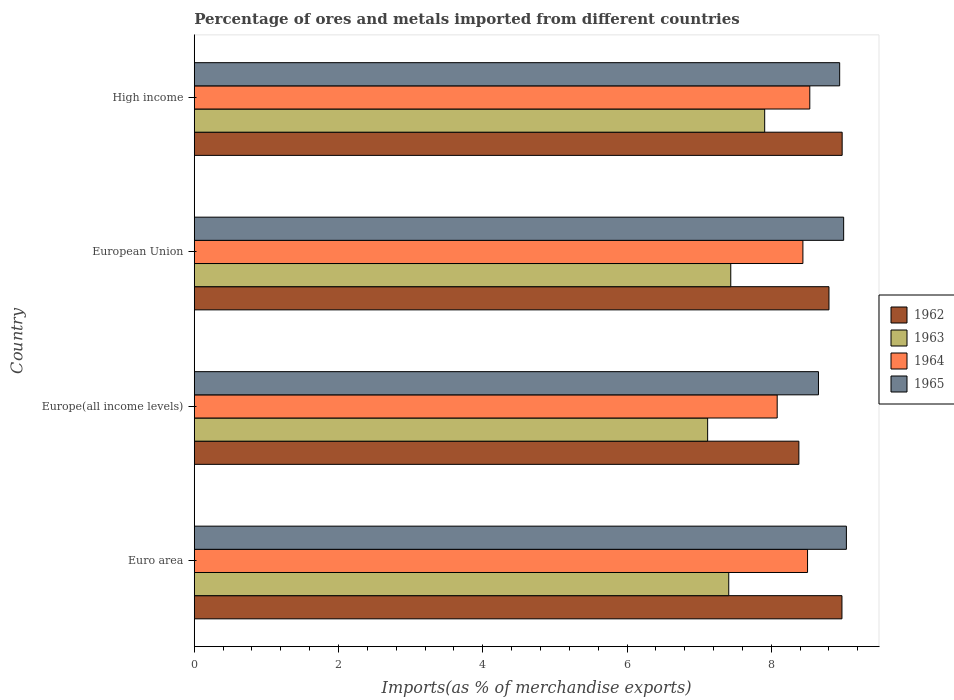How many bars are there on the 1st tick from the top?
Your answer should be very brief. 4. What is the label of the 2nd group of bars from the top?
Ensure brevity in your answer.  European Union. What is the percentage of imports to different countries in 1963 in Euro area?
Offer a very short reply. 7.41. Across all countries, what is the maximum percentage of imports to different countries in 1965?
Offer a very short reply. 9.04. Across all countries, what is the minimum percentage of imports to different countries in 1962?
Provide a succinct answer. 8.38. In which country was the percentage of imports to different countries in 1965 minimum?
Provide a short and direct response. Europe(all income levels). What is the total percentage of imports to different countries in 1963 in the graph?
Offer a very short reply. 29.88. What is the difference between the percentage of imports to different countries in 1964 in Euro area and that in High income?
Ensure brevity in your answer.  -0.03. What is the difference between the percentage of imports to different countries in 1964 in High income and the percentage of imports to different countries in 1965 in Europe(all income levels)?
Offer a very short reply. -0.12. What is the average percentage of imports to different countries in 1963 per country?
Keep it short and to the point. 7.47. What is the difference between the percentage of imports to different countries in 1964 and percentage of imports to different countries in 1965 in European Union?
Keep it short and to the point. -0.56. In how many countries, is the percentage of imports to different countries in 1962 greater than 0.8 %?
Give a very brief answer. 4. What is the ratio of the percentage of imports to different countries in 1963 in Euro area to that in High income?
Offer a terse response. 0.94. Is the percentage of imports to different countries in 1965 in Europe(all income levels) less than that in European Union?
Keep it short and to the point. Yes. Is the difference between the percentage of imports to different countries in 1964 in Euro area and High income greater than the difference between the percentage of imports to different countries in 1965 in Euro area and High income?
Offer a very short reply. No. What is the difference between the highest and the second highest percentage of imports to different countries in 1964?
Give a very brief answer. 0.03. What is the difference between the highest and the lowest percentage of imports to different countries in 1963?
Provide a short and direct response. 0.79. Is the sum of the percentage of imports to different countries in 1965 in Euro area and High income greater than the maximum percentage of imports to different countries in 1964 across all countries?
Provide a succinct answer. Yes. Is it the case that in every country, the sum of the percentage of imports to different countries in 1962 and percentage of imports to different countries in 1965 is greater than the sum of percentage of imports to different countries in 1964 and percentage of imports to different countries in 1963?
Provide a short and direct response. No. What does the 4th bar from the top in European Union represents?
Offer a terse response. 1962. What does the 1st bar from the bottom in Euro area represents?
Provide a succinct answer. 1962. What is the difference between two consecutive major ticks on the X-axis?
Offer a terse response. 2. Are the values on the major ticks of X-axis written in scientific E-notation?
Keep it short and to the point. No. How many legend labels are there?
Keep it short and to the point. 4. What is the title of the graph?
Provide a short and direct response. Percentage of ores and metals imported from different countries. What is the label or title of the X-axis?
Give a very brief answer. Imports(as % of merchandise exports). What is the label or title of the Y-axis?
Your response must be concise. Country. What is the Imports(as % of merchandise exports) in 1962 in Euro area?
Give a very brief answer. 8.98. What is the Imports(as % of merchandise exports) of 1963 in Euro area?
Your response must be concise. 7.41. What is the Imports(as % of merchandise exports) in 1964 in Euro area?
Provide a short and direct response. 8.5. What is the Imports(as % of merchandise exports) in 1965 in Euro area?
Provide a succinct answer. 9.04. What is the Imports(as % of merchandise exports) in 1962 in Europe(all income levels)?
Keep it short and to the point. 8.38. What is the Imports(as % of merchandise exports) in 1963 in Europe(all income levels)?
Your answer should be compact. 7.12. What is the Imports(as % of merchandise exports) of 1964 in Europe(all income levels)?
Give a very brief answer. 8.08. What is the Imports(as % of merchandise exports) of 1965 in Europe(all income levels)?
Your response must be concise. 8.65. What is the Imports(as % of merchandise exports) of 1962 in European Union?
Give a very brief answer. 8.8. What is the Imports(as % of merchandise exports) in 1963 in European Union?
Offer a terse response. 7.44. What is the Imports(as % of merchandise exports) in 1964 in European Union?
Your answer should be very brief. 8.44. What is the Imports(as % of merchandise exports) of 1965 in European Union?
Provide a short and direct response. 9. What is the Imports(as % of merchandise exports) of 1962 in High income?
Provide a succinct answer. 8.98. What is the Imports(as % of merchandise exports) in 1963 in High income?
Give a very brief answer. 7.91. What is the Imports(as % of merchandise exports) in 1964 in High income?
Your answer should be very brief. 8.53. What is the Imports(as % of merchandise exports) in 1965 in High income?
Keep it short and to the point. 8.95. Across all countries, what is the maximum Imports(as % of merchandise exports) in 1962?
Offer a terse response. 8.98. Across all countries, what is the maximum Imports(as % of merchandise exports) of 1963?
Make the answer very short. 7.91. Across all countries, what is the maximum Imports(as % of merchandise exports) of 1964?
Keep it short and to the point. 8.53. Across all countries, what is the maximum Imports(as % of merchandise exports) in 1965?
Keep it short and to the point. 9.04. Across all countries, what is the minimum Imports(as % of merchandise exports) of 1962?
Offer a terse response. 8.38. Across all countries, what is the minimum Imports(as % of merchandise exports) in 1963?
Your response must be concise. 7.12. Across all countries, what is the minimum Imports(as % of merchandise exports) in 1964?
Give a very brief answer. 8.08. Across all countries, what is the minimum Imports(as % of merchandise exports) of 1965?
Ensure brevity in your answer.  8.65. What is the total Imports(as % of merchandise exports) of 1962 in the graph?
Offer a very short reply. 35.15. What is the total Imports(as % of merchandise exports) of 1963 in the graph?
Your answer should be very brief. 29.88. What is the total Imports(as % of merchandise exports) in 1964 in the graph?
Make the answer very short. 33.56. What is the total Imports(as % of merchandise exports) in 1965 in the graph?
Provide a short and direct response. 35.65. What is the difference between the Imports(as % of merchandise exports) in 1962 in Euro area and that in Europe(all income levels)?
Keep it short and to the point. 0.6. What is the difference between the Imports(as % of merchandise exports) of 1963 in Euro area and that in Europe(all income levels)?
Offer a terse response. 0.29. What is the difference between the Imports(as % of merchandise exports) of 1964 in Euro area and that in Europe(all income levels)?
Provide a succinct answer. 0.42. What is the difference between the Imports(as % of merchandise exports) of 1965 in Euro area and that in Europe(all income levels)?
Your answer should be compact. 0.39. What is the difference between the Imports(as % of merchandise exports) in 1962 in Euro area and that in European Union?
Ensure brevity in your answer.  0.18. What is the difference between the Imports(as % of merchandise exports) in 1963 in Euro area and that in European Union?
Your answer should be very brief. -0.03. What is the difference between the Imports(as % of merchandise exports) of 1964 in Euro area and that in European Union?
Your answer should be very brief. 0.06. What is the difference between the Imports(as % of merchandise exports) in 1965 in Euro area and that in European Union?
Provide a short and direct response. 0.04. What is the difference between the Imports(as % of merchandise exports) of 1962 in Euro area and that in High income?
Offer a terse response. -0. What is the difference between the Imports(as % of merchandise exports) of 1963 in Euro area and that in High income?
Your answer should be very brief. -0.5. What is the difference between the Imports(as % of merchandise exports) of 1964 in Euro area and that in High income?
Provide a succinct answer. -0.03. What is the difference between the Imports(as % of merchandise exports) of 1965 in Euro area and that in High income?
Keep it short and to the point. 0.09. What is the difference between the Imports(as % of merchandise exports) in 1962 in Europe(all income levels) and that in European Union?
Offer a very short reply. -0.42. What is the difference between the Imports(as % of merchandise exports) in 1963 in Europe(all income levels) and that in European Union?
Your answer should be very brief. -0.32. What is the difference between the Imports(as % of merchandise exports) of 1964 in Europe(all income levels) and that in European Union?
Give a very brief answer. -0.36. What is the difference between the Imports(as % of merchandise exports) in 1965 in Europe(all income levels) and that in European Union?
Your answer should be compact. -0.35. What is the difference between the Imports(as % of merchandise exports) in 1962 in Europe(all income levels) and that in High income?
Provide a succinct answer. -0.6. What is the difference between the Imports(as % of merchandise exports) in 1963 in Europe(all income levels) and that in High income?
Your response must be concise. -0.79. What is the difference between the Imports(as % of merchandise exports) of 1964 in Europe(all income levels) and that in High income?
Provide a succinct answer. -0.45. What is the difference between the Imports(as % of merchandise exports) in 1965 in Europe(all income levels) and that in High income?
Offer a very short reply. -0.29. What is the difference between the Imports(as % of merchandise exports) of 1962 in European Union and that in High income?
Make the answer very short. -0.18. What is the difference between the Imports(as % of merchandise exports) in 1963 in European Union and that in High income?
Your answer should be very brief. -0.47. What is the difference between the Imports(as % of merchandise exports) in 1964 in European Union and that in High income?
Make the answer very short. -0.1. What is the difference between the Imports(as % of merchandise exports) of 1965 in European Union and that in High income?
Provide a succinct answer. 0.06. What is the difference between the Imports(as % of merchandise exports) of 1962 in Euro area and the Imports(as % of merchandise exports) of 1963 in Europe(all income levels)?
Your answer should be compact. 1.86. What is the difference between the Imports(as % of merchandise exports) in 1962 in Euro area and the Imports(as % of merchandise exports) in 1964 in Europe(all income levels)?
Make the answer very short. 0.9. What is the difference between the Imports(as % of merchandise exports) of 1962 in Euro area and the Imports(as % of merchandise exports) of 1965 in Europe(all income levels)?
Ensure brevity in your answer.  0.33. What is the difference between the Imports(as % of merchandise exports) of 1963 in Euro area and the Imports(as % of merchandise exports) of 1964 in Europe(all income levels)?
Provide a short and direct response. -0.67. What is the difference between the Imports(as % of merchandise exports) of 1963 in Euro area and the Imports(as % of merchandise exports) of 1965 in Europe(all income levels)?
Ensure brevity in your answer.  -1.24. What is the difference between the Imports(as % of merchandise exports) in 1964 in Euro area and the Imports(as % of merchandise exports) in 1965 in Europe(all income levels)?
Provide a succinct answer. -0.15. What is the difference between the Imports(as % of merchandise exports) in 1962 in Euro area and the Imports(as % of merchandise exports) in 1963 in European Union?
Your answer should be very brief. 1.54. What is the difference between the Imports(as % of merchandise exports) of 1962 in Euro area and the Imports(as % of merchandise exports) of 1964 in European Union?
Your answer should be very brief. 0.54. What is the difference between the Imports(as % of merchandise exports) of 1962 in Euro area and the Imports(as % of merchandise exports) of 1965 in European Union?
Keep it short and to the point. -0.02. What is the difference between the Imports(as % of merchandise exports) of 1963 in Euro area and the Imports(as % of merchandise exports) of 1964 in European Union?
Offer a very short reply. -1.03. What is the difference between the Imports(as % of merchandise exports) in 1963 in Euro area and the Imports(as % of merchandise exports) in 1965 in European Union?
Your answer should be very brief. -1.59. What is the difference between the Imports(as % of merchandise exports) in 1964 in Euro area and the Imports(as % of merchandise exports) in 1965 in European Union?
Your response must be concise. -0.5. What is the difference between the Imports(as % of merchandise exports) of 1962 in Euro area and the Imports(as % of merchandise exports) of 1963 in High income?
Ensure brevity in your answer.  1.07. What is the difference between the Imports(as % of merchandise exports) in 1962 in Euro area and the Imports(as % of merchandise exports) in 1964 in High income?
Offer a terse response. 0.45. What is the difference between the Imports(as % of merchandise exports) of 1962 in Euro area and the Imports(as % of merchandise exports) of 1965 in High income?
Give a very brief answer. 0.03. What is the difference between the Imports(as % of merchandise exports) of 1963 in Euro area and the Imports(as % of merchandise exports) of 1964 in High income?
Your answer should be compact. -1.12. What is the difference between the Imports(as % of merchandise exports) of 1963 in Euro area and the Imports(as % of merchandise exports) of 1965 in High income?
Make the answer very short. -1.54. What is the difference between the Imports(as % of merchandise exports) in 1964 in Euro area and the Imports(as % of merchandise exports) in 1965 in High income?
Ensure brevity in your answer.  -0.45. What is the difference between the Imports(as % of merchandise exports) in 1962 in Europe(all income levels) and the Imports(as % of merchandise exports) in 1963 in European Union?
Your answer should be very brief. 0.94. What is the difference between the Imports(as % of merchandise exports) in 1962 in Europe(all income levels) and the Imports(as % of merchandise exports) in 1964 in European Union?
Provide a short and direct response. -0.06. What is the difference between the Imports(as % of merchandise exports) in 1962 in Europe(all income levels) and the Imports(as % of merchandise exports) in 1965 in European Union?
Your answer should be very brief. -0.62. What is the difference between the Imports(as % of merchandise exports) of 1963 in Europe(all income levels) and the Imports(as % of merchandise exports) of 1964 in European Union?
Provide a short and direct response. -1.32. What is the difference between the Imports(as % of merchandise exports) in 1963 in Europe(all income levels) and the Imports(as % of merchandise exports) in 1965 in European Union?
Provide a succinct answer. -1.89. What is the difference between the Imports(as % of merchandise exports) in 1964 in Europe(all income levels) and the Imports(as % of merchandise exports) in 1965 in European Union?
Provide a short and direct response. -0.92. What is the difference between the Imports(as % of merchandise exports) of 1962 in Europe(all income levels) and the Imports(as % of merchandise exports) of 1963 in High income?
Give a very brief answer. 0.47. What is the difference between the Imports(as % of merchandise exports) of 1962 in Europe(all income levels) and the Imports(as % of merchandise exports) of 1964 in High income?
Offer a terse response. -0.15. What is the difference between the Imports(as % of merchandise exports) in 1962 in Europe(all income levels) and the Imports(as % of merchandise exports) in 1965 in High income?
Provide a succinct answer. -0.57. What is the difference between the Imports(as % of merchandise exports) of 1963 in Europe(all income levels) and the Imports(as % of merchandise exports) of 1964 in High income?
Your answer should be very brief. -1.42. What is the difference between the Imports(as % of merchandise exports) of 1963 in Europe(all income levels) and the Imports(as % of merchandise exports) of 1965 in High income?
Offer a very short reply. -1.83. What is the difference between the Imports(as % of merchandise exports) in 1964 in Europe(all income levels) and the Imports(as % of merchandise exports) in 1965 in High income?
Your answer should be very brief. -0.87. What is the difference between the Imports(as % of merchandise exports) in 1962 in European Union and the Imports(as % of merchandise exports) in 1963 in High income?
Offer a terse response. 0.89. What is the difference between the Imports(as % of merchandise exports) in 1962 in European Union and the Imports(as % of merchandise exports) in 1964 in High income?
Keep it short and to the point. 0.27. What is the difference between the Imports(as % of merchandise exports) in 1962 in European Union and the Imports(as % of merchandise exports) in 1965 in High income?
Give a very brief answer. -0.15. What is the difference between the Imports(as % of merchandise exports) in 1963 in European Union and the Imports(as % of merchandise exports) in 1964 in High income?
Keep it short and to the point. -1.1. What is the difference between the Imports(as % of merchandise exports) of 1963 in European Union and the Imports(as % of merchandise exports) of 1965 in High income?
Provide a succinct answer. -1.51. What is the difference between the Imports(as % of merchandise exports) of 1964 in European Union and the Imports(as % of merchandise exports) of 1965 in High income?
Your answer should be very brief. -0.51. What is the average Imports(as % of merchandise exports) of 1962 per country?
Provide a succinct answer. 8.79. What is the average Imports(as % of merchandise exports) in 1963 per country?
Keep it short and to the point. 7.47. What is the average Imports(as % of merchandise exports) in 1964 per country?
Offer a very short reply. 8.39. What is the average Imports(as % of merchandise exports) in 1965 per country?
Make the answer very short. 8.91. What is the difference between the Imports(as % of merchandise exports) of 1962 and Imports(as % of merchandise exports) of 1963 in Euro area?
Your answer should be very brief. 1.57. What is the difference between the Imports(as % of merchandise exports) of 1962 and Imports(as % of merchandise exports) of 1964 in Euro area?
Your response must be concise. 0.48. What is the difference between the Imports(as % of merchandise exports) of 1962 and Imports(as % of merchandise exports) of 1965 in Euro area?
Your response must be concise. -0.06. What is the difference between the Imports(as % of merchandise exports) in 1963 and Imports(as % of merchandise exports) in 1964 in Euro area?
Your answer should be very brief. -1.09. What is the difference between the Imports(as % of merchandise exports) of 1963 and Imports(as % of merchandise exports) of 1965 in Euro area?
Offer a very short reply. -1.63. What is the difference between the Imports(as % of merchandise exports) in 1964 and Imports(as % of merchandise exports) in 1965 in Euro area?
Offer a terse response. -0.54. What is the difference between the Imports(as % of merchandise exports) in 1962 and Imports(as % of merchandise exports) in 1963 in Europe(all income levels)?
Provide a short and direct response. 1.26. What is the difference between the Imports(as % of merchandise exports) in 1962 and Imports(as % of merchandise exports) in 1964 in Europe(all income levels)?
Give a very brief answer. 0.3. What is the difference between the Imports(as % of merchandise exports) in 1962 and Imports(as % of merchandise exports) in 1965 in Europe(all income levels)?
Offer a very short reply. -0.27. What is the difference between the Imports(as % of merchandise exports) of 1963 and Imports(as % of merchandise exports) of 1964 in Europe(all income levels)?
Provide a short and direct response. -0.96. What is the difference between the Imports(as % of merchandise exports) in 1963 and Imports(as % of merchandise exports) in 1965 in Europe(all income levels)?
Your answer should be very brief. -1.54. What is the difference between the Imports(as % of merchandise exports) of 1964 and Imports(as % of merchandise exports) of 1965 in Europe(all income levels)?
Ensure brevity in your answer.  -0.57. What is the difference between the Imports(as % of merchandise exports) of 1962 and Imports(as % of merchandise exports) of 1963 in European Union?
Provide a short and direct response. 1.36. What is the difference between the Imports(as % of merchandise exports) in 1962 and Imports(as % of merchandise exports) in 1964 in European Union?
Provide a short and direct response. 0.36. What is the difference between the Imports(as % of merchandise exports) of 1962 and Imports(as % of merchandise exports) of 1965 in European Union?
Your response must be concise. -0.2. What is the difference between the Imports(as % of merchandise exports) in 1963 and Imports(as % of merchandise exports) in 1964 in European Union?
Make the answer very short. -1. What is the difference between the Imports(as % of merchandise exports) in 1963 and Imports(as % of merchandise exports) in 1965 in European Union?
Provide a short and direct response. -1.57. What is the difference between the Imports(as % of merchandise exports) in 1964 and Imports(as % of merchandise exports) in 1965 in European Union?
Your answer should be very brief. -0.56. What is the difference between the Imports(as % of merchandise exports) of 1962 and Imports(as % of merchandise exports) of 1963 in High income?
Provide a short and direct response. 1.07. What is the difference between the Imports(as % of merchandise exports) of 1962 and Imports(as % of merchandise exports) of 1964 in High income?
Offer a terse response. 0.45. What is the difference between the Imports(as % of merchandise exports) of 1962 and Imports(as % of merchandise exports) of 1965 in High income?
Offer a terse response. 0.03. What is the difference between the Imports(as % of merchandise exports) of 1963 and Imports(as % of merchandise exports) of 1964 in High income?
Your answer should be compact. -0.63. What is the difference between the Imports(as % of merchandise exports) in 1963 and Imports(as % of merchandise exports) in 1965 in High income?
Offer a very short reply. -1.04. What is the difference between the Imports(as % of merchandise exports) of 1964 and Imports(as % of merchandise exports) of 1965 in High income?
Offer a terse response. -0.41. What is the ratio of the Imports(as % of merchandise exports) in 1962 in Euro area to that in Europe(all income levels)?
Ensure brevity in your answer.  1.07. What is the ratio of the Imports(as % of merchandise exports) in 1963 in Euro area to that in Europe(all income levels)?
Your answer should be compact. 1.04. What is the ratio of the Imports(as % of merchandise exports) of 1964 in Euro area to that in Europe(all income levels)?
Your response must be concise. 1.05. What is the ratio of the Imports(as % of merchandise exports) of 1965 in Euro area to that in Europe(all income levels)?
Ensure brevity in your answer.  1.04. What is the ratio of the Imports(as % of merchandise exports) of 1962 in Euro area to that in European Union?
Ensure brevity in your answer.  1.02. What is the ratio of the Imports(as % of merchandise exports) in 1964 in Euro area to that in European Union?
Your answer should be very brief. 1.01. What is the ratio of the Imports(as % of merchandise exports) of 1965 in Euro area to that in European Union?
Your response must be concise. 1. What is the ratio of the Imports(as % of merchandise exports) in 1962 in Euro area to that in High income?
Offer a terse response. 1. What is the ratio of the Imports(as % of merchandise exports) of 1963 in Euro area to that in High income?
Offer a very short reply. 0.94. What is the ratio of the Imports(as % of merchandise exports) of 1965 in Euro area to that in High income?
Provide a succinct answer. 1.01. What is the ratio of the Imports(as % of merchandise exports) in 1962 in Europe(all income levels) to that in European Union?
Your answer should be compact. 0.95. What is the ratio of the Imports(as % of merchandise exports) in 1963 in Europe(all income levels) to that in European Union?
Give a very brief answer. 0.96. What is the ratio of the Imports(as % of merchandise exports) of 1964 in Europe(all income levels) to that in European Union?
Ensure brevity in your answer.  0.96. What is the ratio of the Imports(as % of merchandise exports) in 1965 in Europe(all income levels) to that in European Union?
Provide a short and direct response. 0.96. What is the ratio of the Imports(as % of merchandise exports) in 1962 in Europe(all income levels) to that in High income?
Keep it short and to the point. 0.93. What is the ratio of the Imports(as % of merchandise exports) in 1964 in Europe(all income levels) to that in High income?
Your answer should be very brief. 0.95. What is the ratio of the Imports(as % of merchandise exports) in 1965 in Europe(all income levels) to that in High income?
Provide a succinct answer. 0.97. What is the ratio of the Imports(as % of merchandise exports) in 1962 in European Union to that in High income?
Keep it short and to the point. 0.98. What is the ratio of the Imports(as % of merchandise exports) of 1963 in European Union to that in High income?
Provide a succinct answer. 0.94. What is the difference between the highest and the second highest Imports(as % of merchandise exports) in 1962?
Provide a short and direct response. 0. What is the difference between the highest and the second highest Imports(as % of merchandise exports) of 1963?
Provide a succinct answer. 0.47. What is the difference between the highest and the second highest Imports(as % of merchandise exports) of 1964?
Offer a very short reply. 0.03. What is the difference between the highest and the second highest Imports(as % of merchandise exports) of 1965?
Provide a succinct answer. 0.04. What is the difference between the highest and the lowest Imports(as % of merchandise exports) of 1962?
Your response must be concise. 0.6. What is the difference between the highest and the lowest Imports(as % of merchandise exports) in 1963?
Provide a succinct answer. 0.79. What is the difference between the highest and the lowest Imports(as % of merchandise exports) of 1964?
Make the answer very short. 0.45. What is the difference between the highest and the lowest Imports(as % of merchandise exports) of 1965?
Make the answer very short. 0.39. 